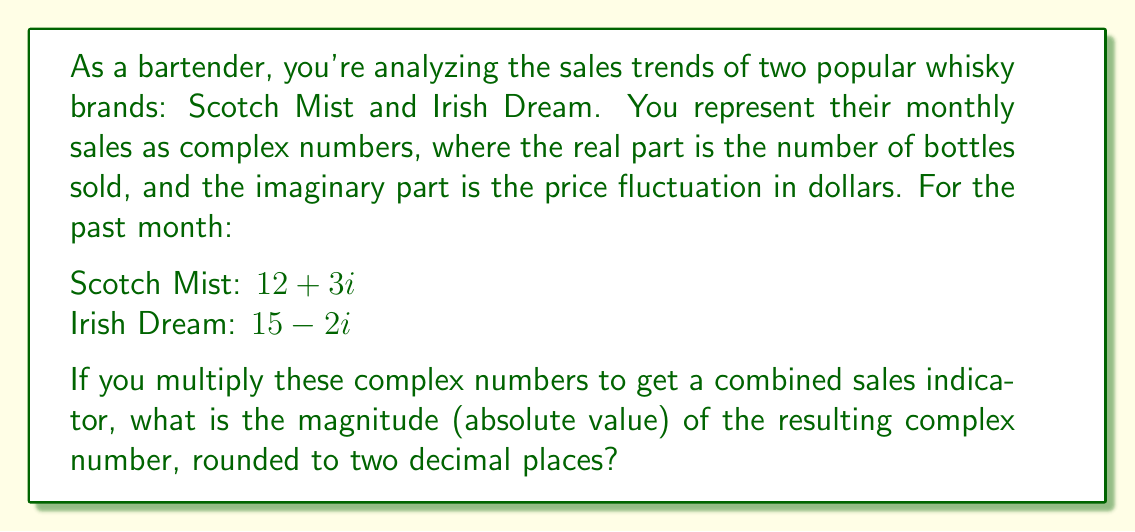Can you answer this question? To solve this problem, we'll follow these steps:

1) First, let's multiply the two complex numbers:
   $$(12 + 3i)(15 - 2i)$$

2) We can use the FOIL method or distribute:
   $$12(15) + 12(-2i) + 3i(15) + 3i(-2i)$$
   $$= 180 - 24i + 45i - 6i^2$$

3) Simplify, remembering that $i^2 = -1$:
   $$= 180 + 21i + 6$$
   $$= 186 + 21i$$

4) Now we have our resulting complex number. To find its magnitude, we use the formula:
   $$|a + bi| = \sqrt{a^2 + b^2}$$

5) In this case:
   $$|186 + 21i| = \sqrt{186^2 + 21^2}$$

6) Calculate:
   $$\sqrt{34596 + 441} = \sqrt{35037} \approx 187.18$$

7) Rounding to two decimal places gives us 187.18.

This final number represents a combined sales indicator, taking into account both the number of bottles sold and the price fluctuations for both whisky brands.
Answer: 187.18 